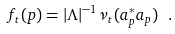<formula> <loc_0><loc_0><loc_500><loc_500>f _ { t } ( p ) = | \Lambda | ^ { - 1 } { \nu _ { t } ( a _ { p } ^ { * } a _ { p } ) } \ .</formula> 